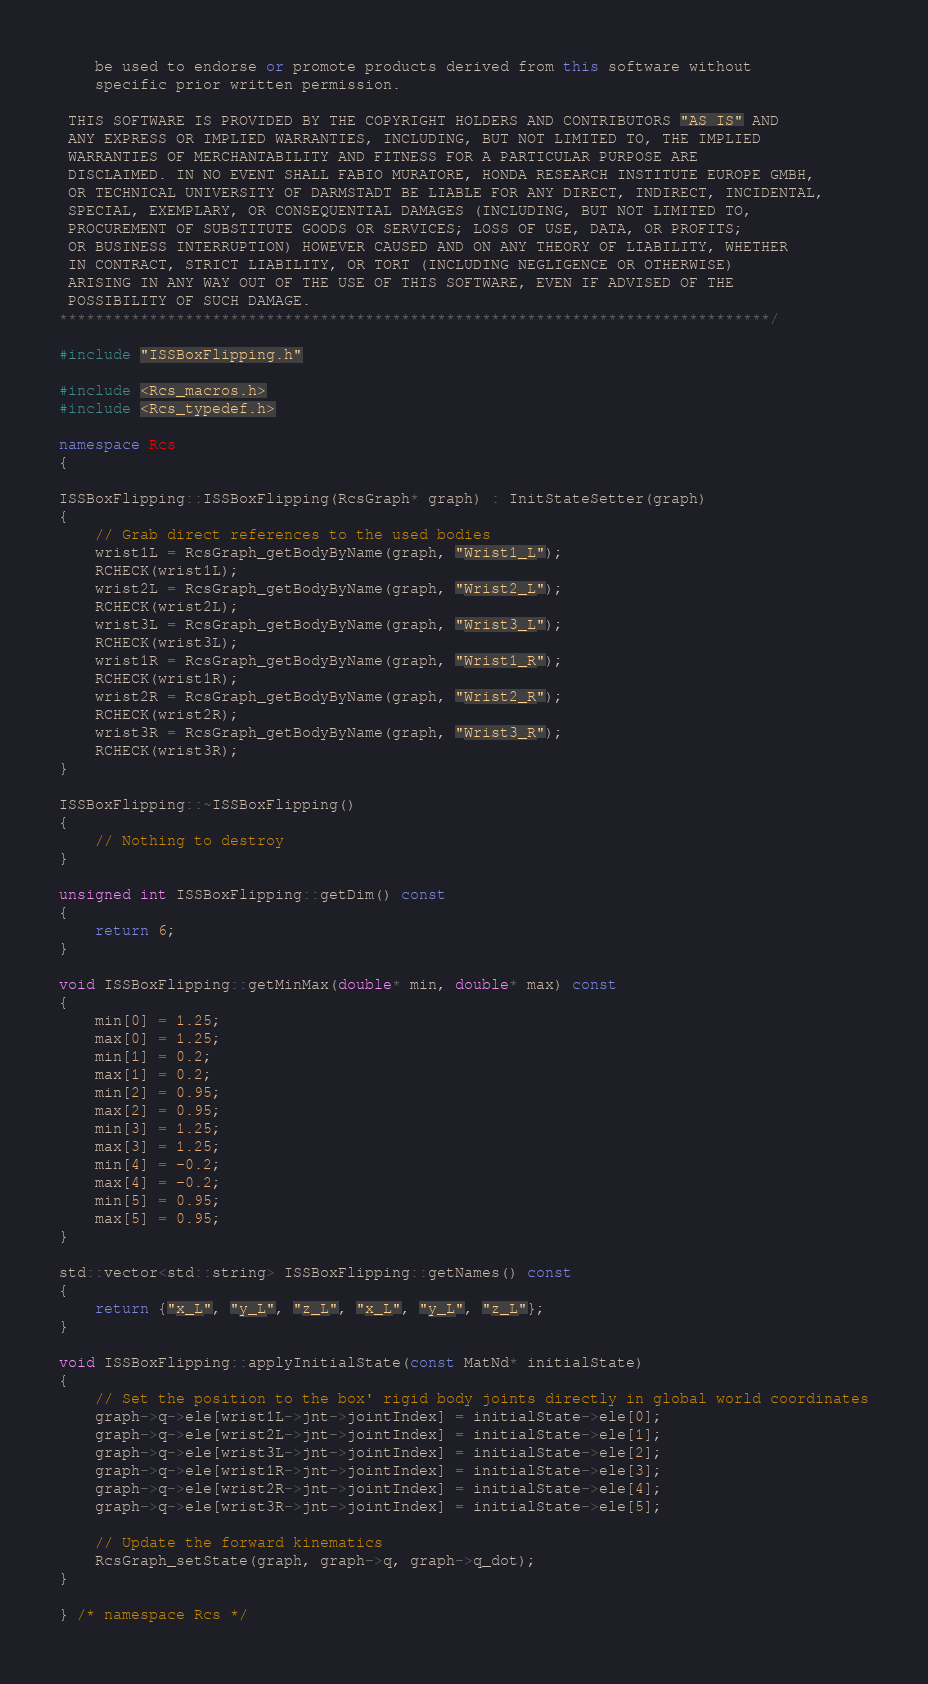Convert code to text. <code><loc_0><loc_0><loc_500><loc_500><_C++_>    be used to endorse or promote products derived from this software without
    specific prior written permission.

 THIS SOFTWARE IS PROVIDED BY THE COPYRIGHT HOLDERS AND CONTRIBUTORS "AS IS" AND
 ANY EXPRESS OR IMPLIED WARRANTIES, INCLUDING, BUT NOT LIMITED TO, THE IMPLIED
 WARRANTIES OF MERCHANTABILITY AND FITNESS FOR A PARTICULAR PURPOSE ARE
 DISCLAIMED. IN NO EVENT SHALL FABIO MURATORE, HONDA RESEARCH INSTITUTE EUROPE GMBH,
 OR TECHNICAL UNIVERSITY OF DARMSTADT BE LIABLE FOR ANY DIRECT, INDIRECT, INCIDENTAL,
 SPECIAL, EXEMPLARY, OR CONSEQUENTIAL DAMAGES (INCLUDING, BUT NOT LIMITED TO,
 PROCUREMENT OF SUBSTITUTE GOODS OR SERVICES; LOSS OF USE, DATA, OR PROFITS;
 OR BUSINESS INTERRUPTION) HOWEVER CAUSED AND ON ANY THEORY OF LIABILITY, WHETHER
 IN CONTRACT, STRICT LIABILITY, OR TORT (INCLUDING NEGLIGENCE OR OTHERWISE)
 ARISING IN ANY WAY OUT OF THE USE OF THIS SOFTWARE, EVEN IF ADVISED OF THE
 POSSIBILITY OF SUCH DAMAGE.
*******************************************************************************/

#include "ISSBoxFlipping.h"

#include <Rcs_macros.h>
#include <Rcs_typedef.h>

namespace Rcs
{

ISSBoxFlipping::ISSBoxFlipping(RcsGraph* graph) : InitStateSetter(graph)
{
    // Grab direct references to the used bodies
    wrist1L = RcsGraph_getBodyByName(graph, "Wrist1_L");
    RCHECK(wrist1L);
    wrist2L = RcsGraph_getBodyByName(graph, "Wrist2_L");
    RCHECK(wrist2L);
    wrist3L = RcsGraph_getBodyByName(graph, "Wrist3_L");
    RCHECK(wrist3L);
    wrist1R = RcsGraph_getBodyByName(graph, "Wrist1_R");
    RCHECK(wrist1R);
    wrist2R = RcsGraph_getBodyByName(graph, "Wrist2_R");
    RCHECK(wrist2R);
    wrist3R = RcsGraph_getBodyByName(graph, "Wrist3_R");
    RCHECK(wrist3R);
}

ISSBoxFlipping::~ISSBoxFlipping()
{
    // Nothing to destroy
}

unsigned int ISSBoxFlipping::getDim() const
{
    return 6;
}

void ISSBoxFlipping::getMinMax(double* min, double* max) const
{
    min[0] = 1.25;
    max[0] = 1.25;
    min[1] = 0.2;
    max[1] = 0.2;
    min[2] = 0.95;
    max[2] = 0.95;
    min[3] = 1.25;
    max[3] = 1.25;
    min[4] = -0.2;
    max[4] = -0.2;
    min[5] = 0.95;
    max[5] = 0.95;
}

std::vector<std::string> ISSBoxFlipping::getNames() const
{
    return {"x_L", "y_L", "z_L", "x_L", "y_L", "z_L"};
}

void ISSBoxFlipping::applyInitialState(const MatNd* initialState)
{
    // Set the position to the box' rigid body joints directly in global world coordinates
    graph->q->ele[wrist1L->jnt->jointIndex] = initialState->ele[0];
    graph->q->ele[wrist2L->jnt->jointIndex] = initialState->ele[1];
    graph->q->ele[wrist3L->jnt->jointIndex] = initialState->ele[2];
    graph->q->ele[wrist1R->jnt->jointIndex] = initialState->ele[3];
    graph->q->ele[wrist2R->jnt->jointIndex] = initialState->ele[4];
    graph->q->ele[wrist3R->jnt->jointIndex] = initialState->ele[5];
    
    // Update the forward kinematics
    RcsGraph_setState(graph, graph->q, graph->q_dot);
}

} /* namespace Rcs */
</code> 